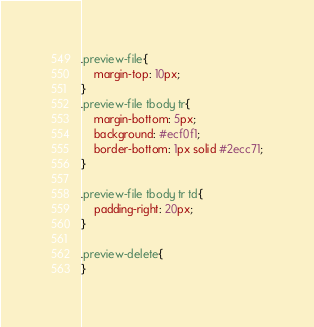<code> <loc_0><loc_0><loc_500><loc_500><_CSS_>

.preview-file{
	margin-top: 10px;
}
.preview-file tbody tr{
	margin-bottom: 5px;
	background: #ecf0f1;
	border-bottom: 1px solid #2ecc71;
}

.preview-file tbody tr td{
	padding-right: 20px;
}

.preview-delete{
}</code> 